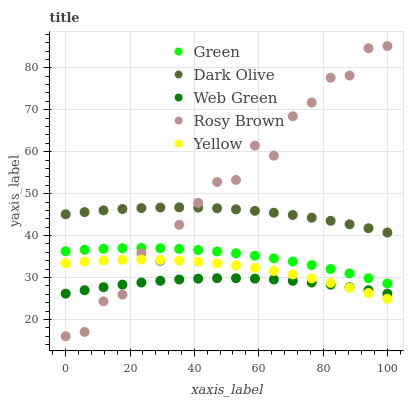Does Web Green have the minimum area under the curve?
Answer yes or no. Yes. Does Rosy Brown have the maximum area under the curve?
Answer yes or no. Yes. Does Dark Olive have the minimum area under the curve?
Answer yes or no. No. Does Dark Olive have the maximum area under the curve?
Answer yes or no. No. Is Dark Olive the smoothest?
Answer yes or no. Yes. Is Rosy Brown the roughest?
Answer yes or no. Yes. Is Green the smoothest?
Answer yes or no. No. Is Green the roughest?
Answer yes or no. No. Does Rosy Brown have the lowest value?
Answer yes or no. Yes. Does Green have the lowest value?
Answer yes or no. No. Does Rosy Brown have the highest value?
Answer yes or no. Yes. Does Dark Olive have the highest value?
Answer yes or no. No. Is Yellow less than Dark Olive?
Answer yes or no. Yes. Is Green greater than Yellow?
Answer yes or no. Yes. Does Web Green intersect Yellow?
Answer yes or no. Yes. Is Web Green less than Yellow?
Answer yes or no. No. Is Web Green greater than Yellow?
Answer yes or no. No. Does Yellow intersect Dark Olive?
Answer yes or no. No. 